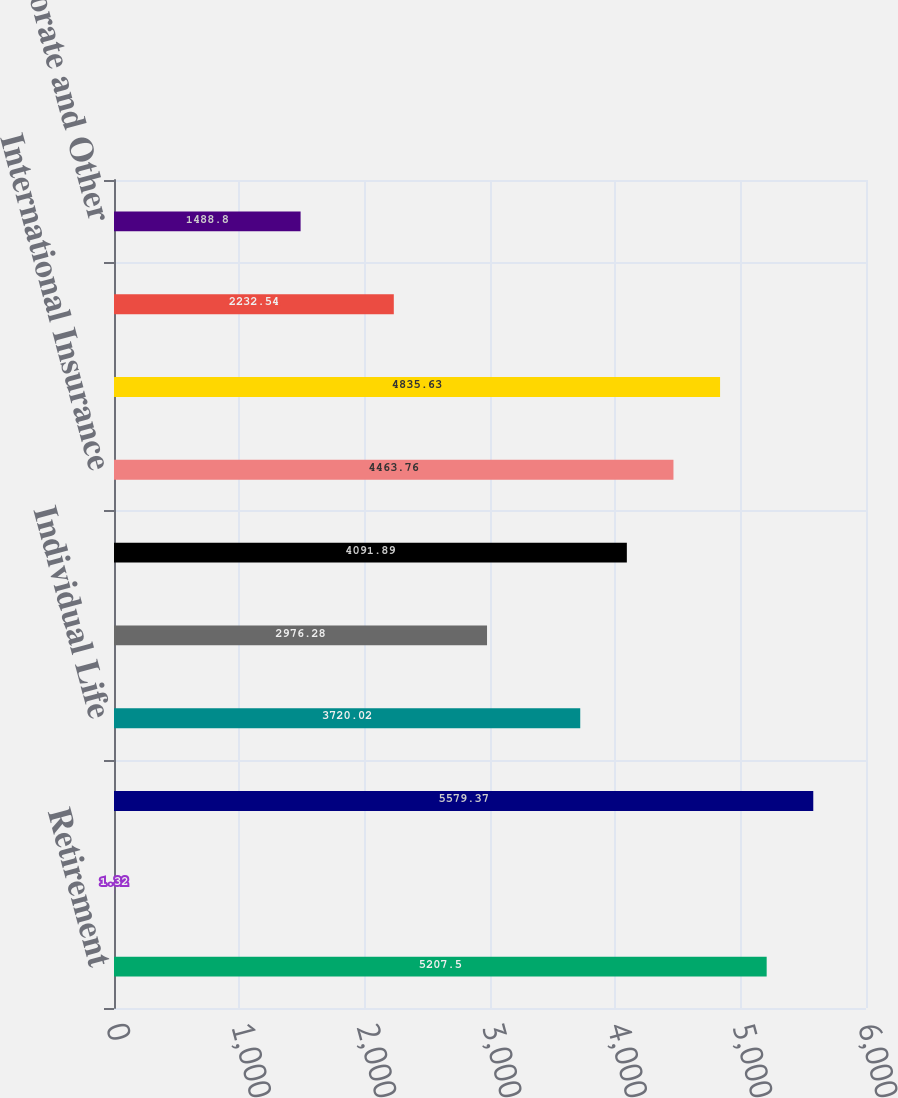<chart> <loc_0><loc_0><loc_500><loc_500><bar_chart><fcel>Retirement<fcel>Asset Management<fcel>Total US Retirement Solutions<fcel>Individual Life<fcel>Group Insurance<fcel>Total US Individual Life and<fcel>International Insurance<fcel>Total International Insurance<fcel>Corporate and Other operations<fcel>Total Corporate and Other<nl><fcel>5207.5<fcel>1.32<fcel>5579.37<fcel>3720.02<fcel>2976.28<fcel>4091.89<fcel>4463.76<fcel>4835.63<fcel>2232.54<fcel>1488.8<nl></chart> 